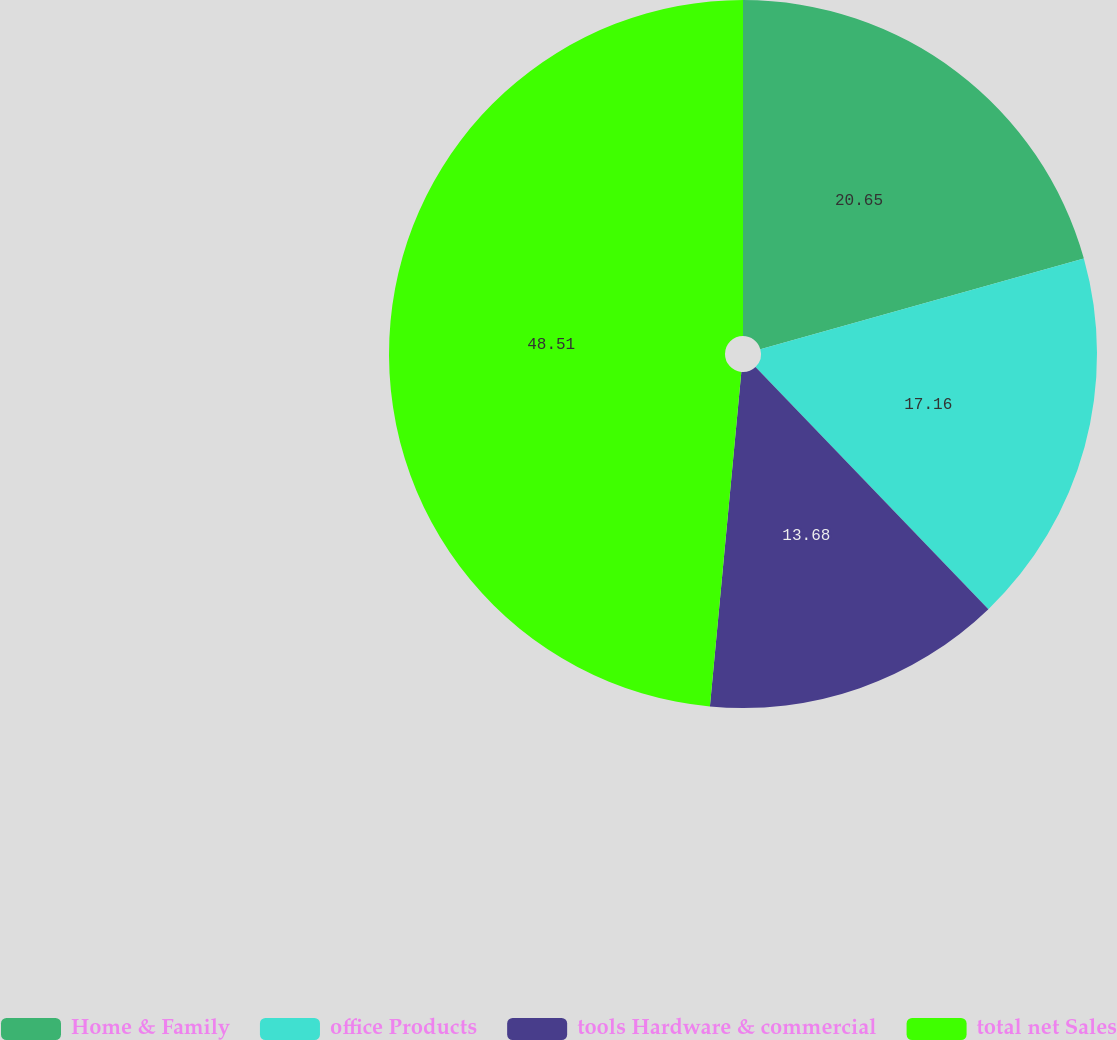Convert chart to OTSL. <chart><loc_0><loc_0><loc_500><loc_500><pie_chart><fcel>Home & Family<fcel>office Products<fcel>tools Hardware & commercial<fcel>total net Sales<nl><fcel>20.65%<fcel>17.16%<fcel>13.68%<fcel>48.51%<nl></chart> 